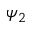Convert formula to latex. <formula><loc_0><loc_0><loc_500><loc_500>\psi _ { 2 }</formula> 